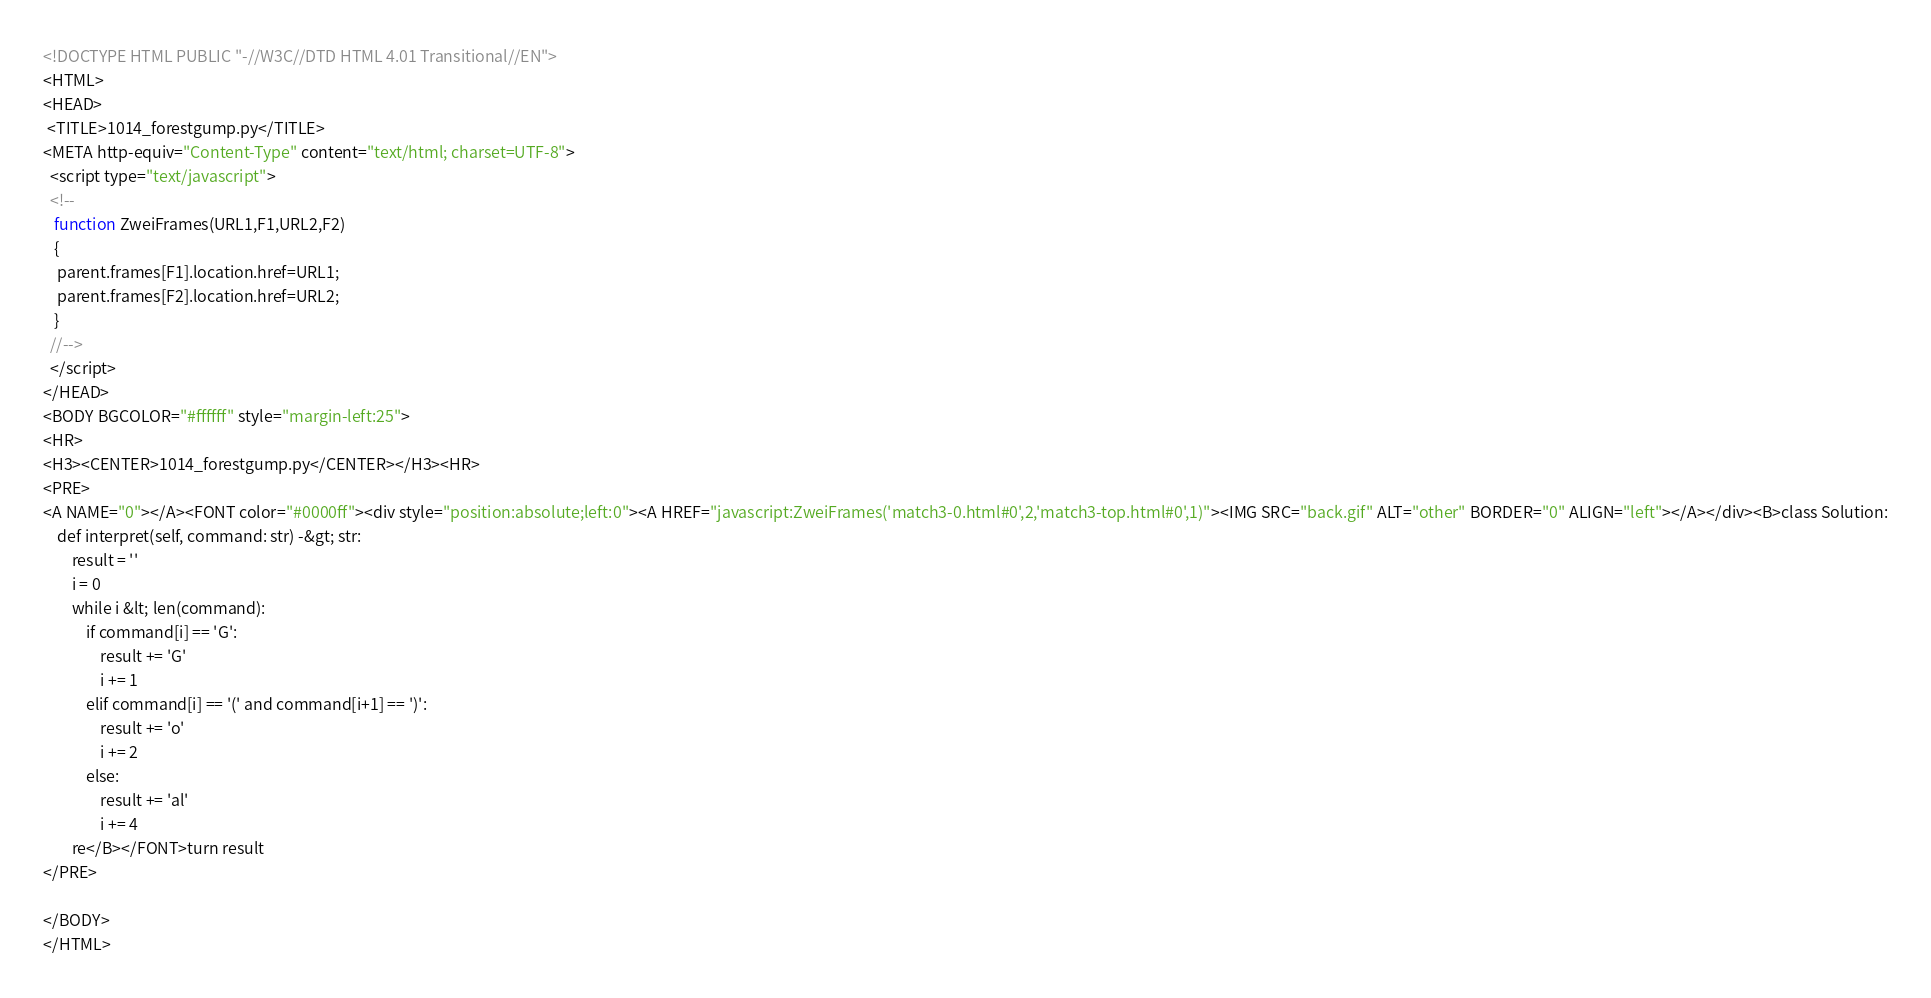<code> <loc_0><loc_0><loc_500><loc_500><_HTML_><!DOCTYPE HTML PUBLIC "-//W3C//DTD HTML 4.01 Transitional//EN">
<HTML>
<HEAD>
 <TITLE>1014_forestgump.py</TITLE>
<META http-equiv="Content-Type" content="text/html; charset=UTF-8">
  <script type="text/javascript">
  <!--
   function ZweiFrames(URL1,F1,URL2,F2)
   {
    parent.frames[F1].location.href=URL1;
    parent.frames[F2].location.href=URL2;
   }
  //-->
  </script>
</HEAD>
<BODY BGCOLOR="#ffffff" style="margin-left:25">
<HR>
<H3><CENTER>1014_forestgump.py</CENTER></H3><HR>
<PRE>
<A NAME="0"></A><FONT color="#0000ff"><div style="position:absolute;left:0"><A HREF="javascript:ZweiFrames('match3-0.html#0',2,'match3-top.html#0',1)"><IMG SRC="back.gif" ALT="other" BORDER="0" ALIGN="left"></A></div><B>class Solution:
    def interpret(self, command: str) -&gt; str:
        result = ''
        i = 0
        while i &lt; len(command):
            if command[i] == 'G':
                result += 'G'
                i += 1
            elif command[i] == '(' and command[i+1] == ')':
                result += 'o'
                i += 2
            else:
                result += 'al'
                i += 4
        re</B></FONT>turn result
</PRE>

</BODY>
</HTML>
</code> 